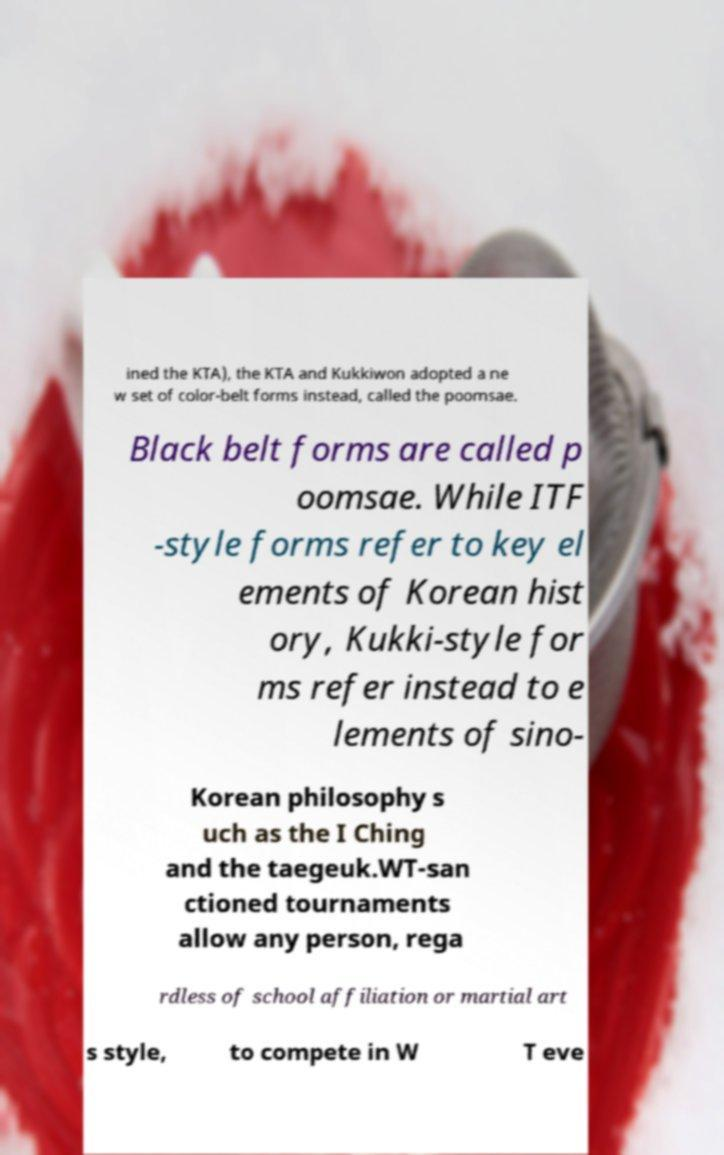Can you accurately transcribe the text from the provided image for me? ined the KTA), the KTA and Kukkiwon adopted a ne w set of color-belt forms instead, called the poomsae. Black belt forms are called p oomsae. While ITF -style forms refer to key el ements of Korean hist ory, Kukki-style for ms refer instead to e lements of sino- Korean philosophy s uch as the I Ching and the taegeuk.WT-san ctioned tournaments allow any person, rega rdless of school affiliation or martial art s style, to compete in W T eve 